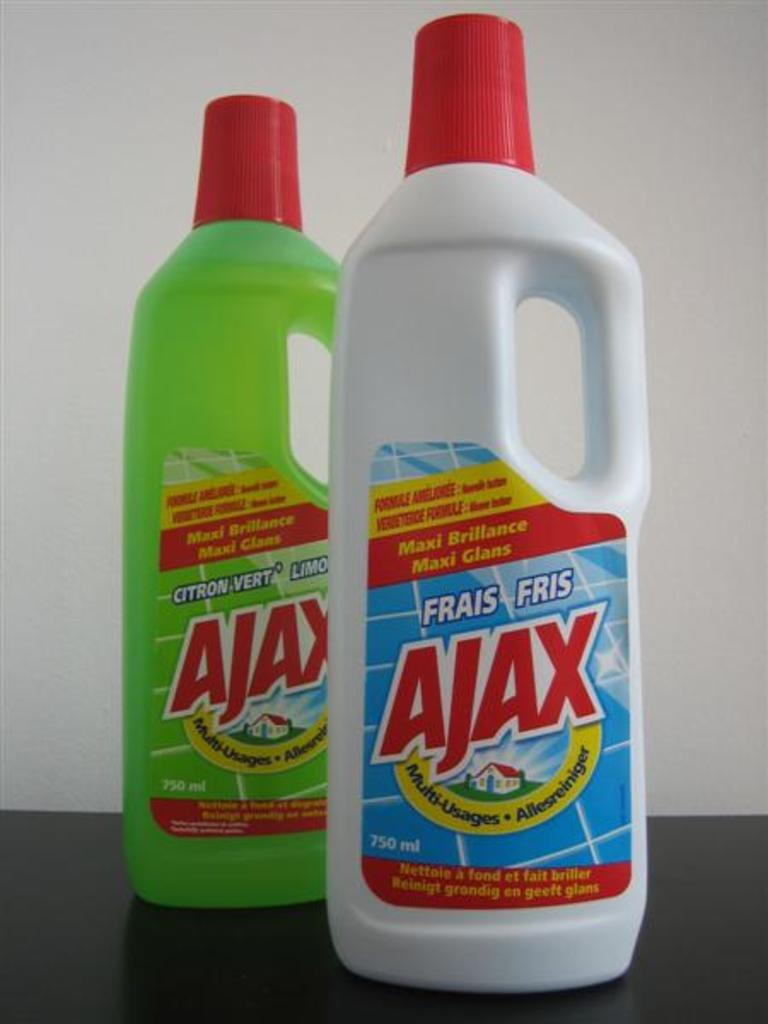<image>
Render a clear and concise summary of the photo. bottles of ajax  maxi brilliance standing next to one another 